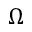<formula> <loc_0><loc_0><loc_500><loc_500>\Omega</formula> 